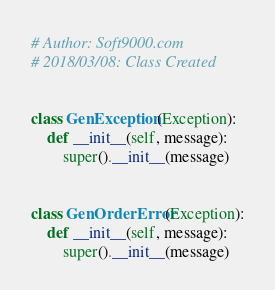<code> <loc_0><loc_0><loc_500><loc_500><_Python_># Author: Soft9000.com
# 2018/03/08: Class Created


class GenException(Exception):
    def __init__(self, message):
        super().__init__(message)


class GenOrderError(Exception):
    def __init__(self, message):
        super().__init__(message)
</code> 